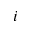Convert formula to latex. <formula><loc_0><loc_0><loc_500><loc_500>i</formula> 